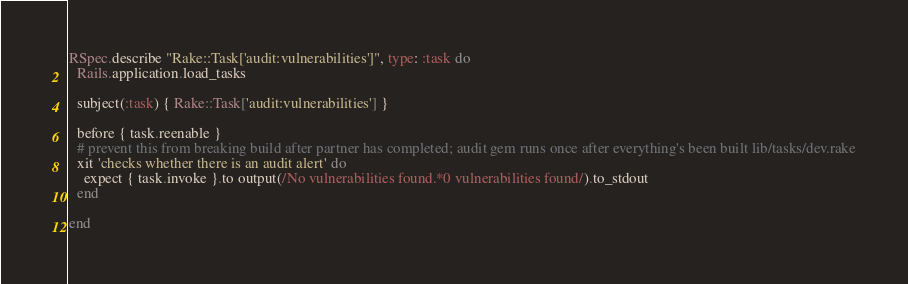<code> <loc_0><loc_0><loc_500><loc_500><_Ruby_>
RSpec.describe "Rake::Task['audit:vulnerabilities']", type: :task do
  Rails.application.load_tasks

  subject(:task) { Rake::Task['audit:vulnerabilities'] }

  before { task.reenable }
  # prevent this from breaking build after partner has completed; audit gem runs once after everything's been built lib/tasks/dev.rake
  xit 'checks whether there is an audit alert' do
    expect { task.invoke }.to output(/No vulnerabilities found.*0 vulnerabilities found/).to_stdout
  end

end</code> 